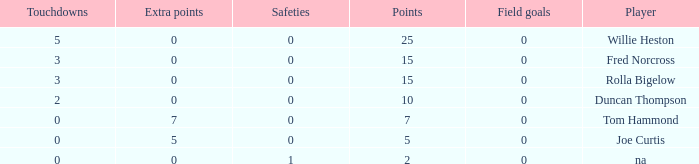How many Touchdowns have a Player of rolla bigelow, and an Extra points smaller than 0? None. 